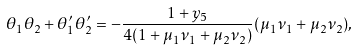Convert formula to latex. <formula><loc_0><loc_0><loc_500><loc_500>\theta _ { 1 } \theta _ { 2 } + \theta ^ { \prime } _ { 1 } \theta ^ { \prime } _ { 2 } = - \frac { 1 + y _ { 5 } } { 4 ( 1 + \mu _ { 1 } \nu _ { 1 } + \mu _ { 2 } \nu _ { 2 } ) } ( \mu _ { 1 } \nu _ { 1 } + \mu _ { 2 } \nu _ { 2 } ) ,</formula> 